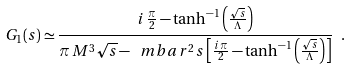<formula> <loc_0><loc_0><loc_500><loc_500>G _ { 1 } ( s ) \simeq \frac { i \, \frac { \pi } { 2 } - \tanh ^ { - 1 } \left ( \frac { \sqrt { s } } { \Lambda } \right ) } { \pi \, M ^ { 3 } \sqrt { s } - \ m b a r ^ { 2 } \, s \left [ \frac { i \, \pi } { 2 } - \tanh ^ { - 1 } \left ( \frac { \sqrt { s } } { \Lambda } \right ) \right ] } \ .</formula> 